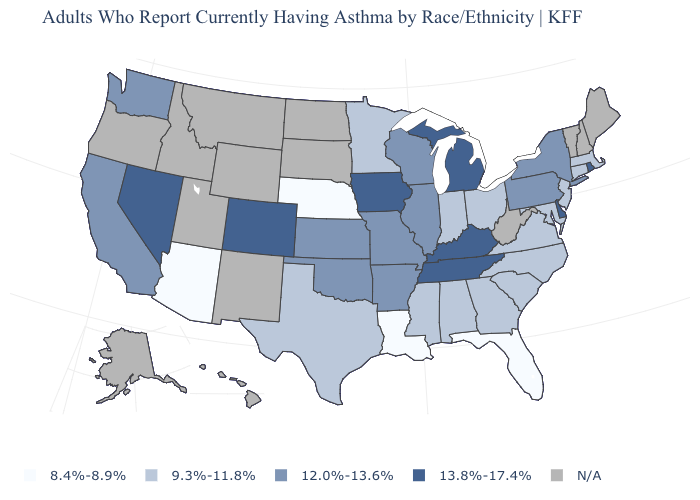What is the value of New Jersey?
Write a very short answer. 9.3%-11.8%. Name the states that have a value in the range 13.8%-17.4%?
Keep it brief. Colorado, Delaware, Iowa, Kentucky, Michigan, Nevada, Rhode Island, Tennessee. What is the value of Virginia?
Answer briefly. 9.3%-11.8%. What is the value of Arkansas?
Short answer required. 12.0%-13.6%. Among the states that border Vermont , which have the highest value?
Write a very short answer. New York. What is the lowest value in states that border Kentucky?
Concise answer only. 9.3%-11.8%. Name the states that have a value in the range 8.4%-8.9%?
Be succinct. Arizona, Florida, Louisiana, Nebraska. Name the states that have a value in the range 8.4%-8.9%?
Quick response, please. Arizona, Florida, Louisiana, Nebraska. What is the lowest value in the Northeast?
Answer briefly. 9.3%-11.8%. Which states have the lowest value in the USA?
Concise answer only. Arizona, Florida, Louisiana, Nebraska. Name the states that have a value in the range 9.3%-11.8%?
Answer briefly. Alabama, Connecticut, Georgia, Indiana, Maryland, Massachusetts, Minnesota, Mississippi, New Jersey, North Carolina, Ohio, South Carolina, Texas, Virginia. What is the value of California?
Write a very short answer. 12.0%-13.6%. What is the highest value in the MidWest ?
Write a very short answer. 13.8%-17.4%. What is the value of Texas?
Give a very brief answer. 9.3%-11.8%. 